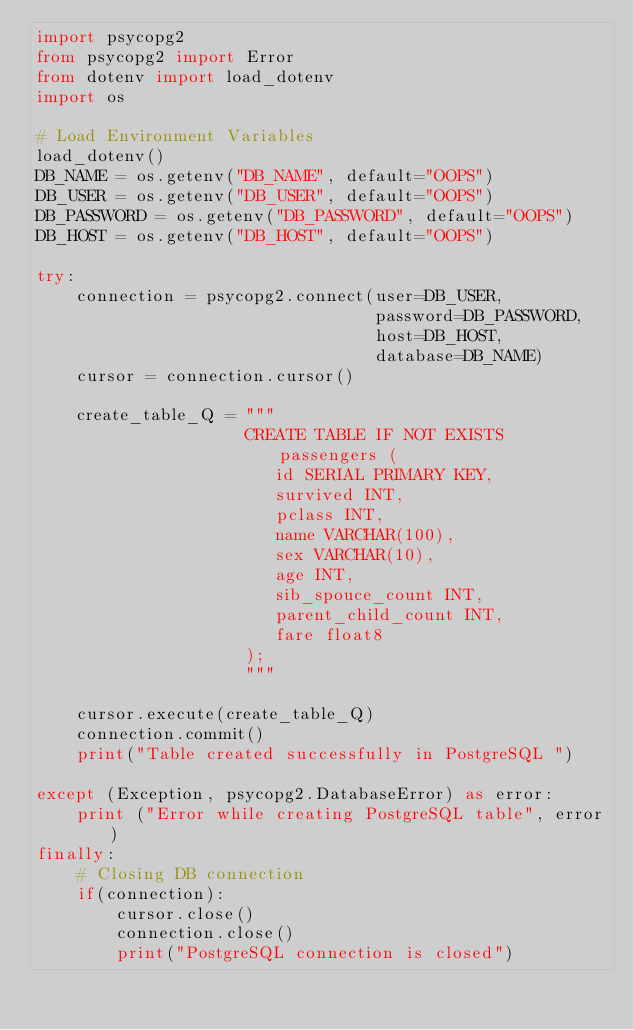<code> <loc_0><loc_0><loc_500><loc_500><_Python_>import psycopg2
from psycopg2 import Error
from dotenv import load_dotenv
import os

# Load Environment Variables
load_dotenv()
DB_NAME = os.getenv("DB_NAME", default="OOPS")
DB_USER = os.getenv("DB_USER", default="OOPS")
DB_PASSWORD = os.getenv("DB_PASSWORD", default="OOPS")
DB_HOST = os.getenv("DB_HOST", default="OOPS")

try:
    connection = psycopg2.connect(user=DB_USER,
                                  password=DB_PASSWORD,
                                  host=DB_HOST,
                                  database=DB_NAME)
    cursor = connection.cursor()

    create_table_Q = """
                     CREATE TABLE IF NOT EXISTS passengers (
                        id SERIAL PRIMARY KEY,
                        survived INT,
                        pclass INT,
                        name VARCHAR(100),
                        sex VARCHAR(10),
                        age INT,
                        sib_spouce_count INT,
                        parent_child_count INT,
                        fare float8
                     );
                     """

    cursor.execute(create_table_Q)
    connection.commit()
    print("Table created successfully in PostgreSQL ")

except (Exception, psycopg2.DatabaseError) as error:
    print ("Error while creating PostgreSQL table", error)
finally:
    # Closing DB connection
    if(connection):
        cursor.close()
        connection.close()
        print("PostgreSQL connection is closed")


    </code> 